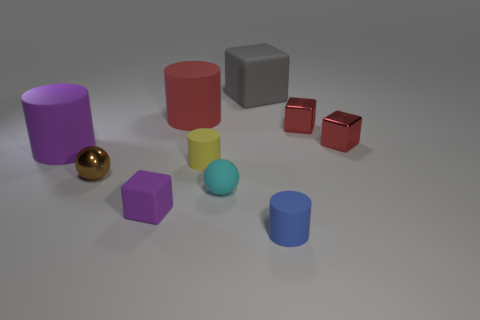How big is the red cylinder?
Provide a short and direct response. Large. There is a purple thing that is on the right side of the purple thing behind the small cylinder behind the purple rubber block; what is its material?
Give a very brief answer. Rubber. How many other objects are there of the same color as the matte ball?
Ensure brevity in your answer.  0. How many purple things are either small blocks or small matte blocks?
Provide a short and direct response. 1. What is the small cylinder that is on the right side of the large gray rubber thing made of?
Your answer should be compact. Rubber. Do the red thing to the left of the large gray matte object and the big gray object have the same material?
Your answer should be very brief. Yes. What is the shape of the yellow object?
Your answer should be very brief. Cylinder. There is a cyan rubber thing behind the cube that is in front of the large purple thing; how many shiny spheres are on the right side of it?
Your response must be concise. 0. What number of other objects are the same material as the large purple cylinder?
Provide a short and direct response. 6. There is a yellow cylinder that is the same size as the blue thing; what material is it?
Your answer should be very brief. Rubber. 